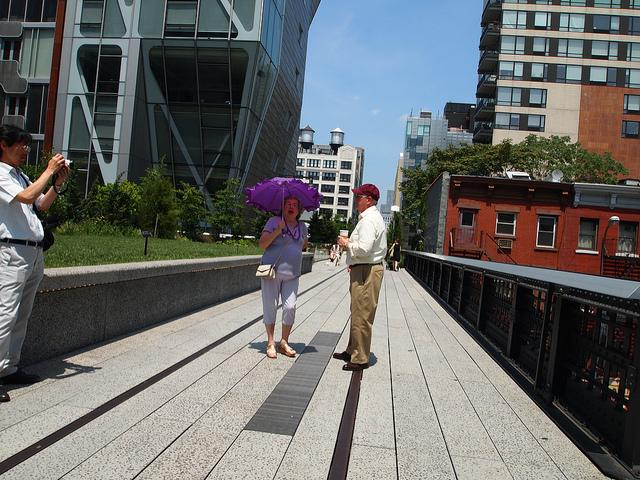The tanks seen in the background above the building once held what? Please explain your reasoning. water. There are old fashioned water tanks, which many buildings used to need before modern modes of water systems were invented. 